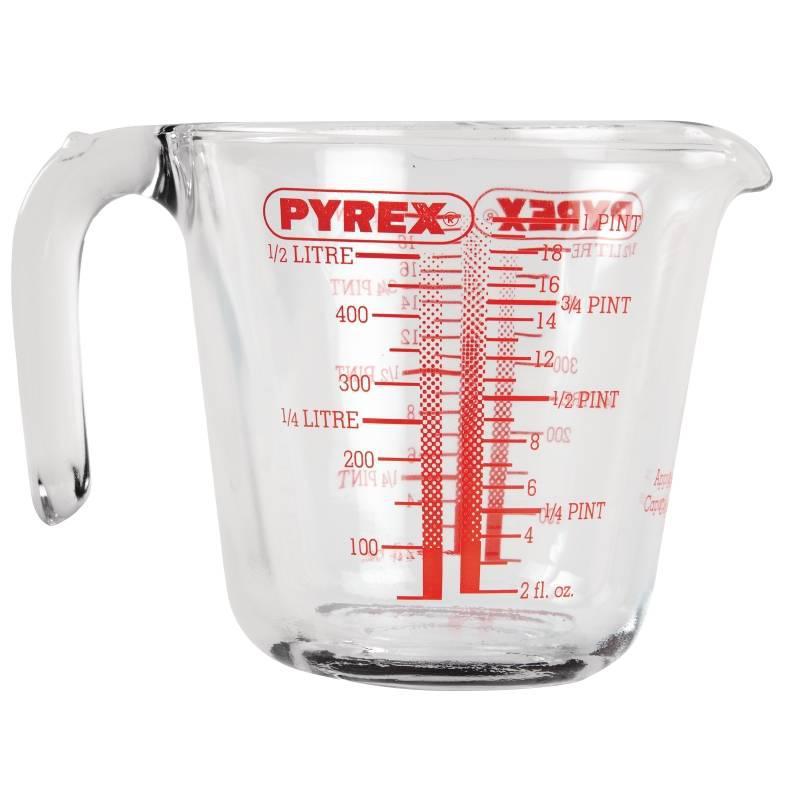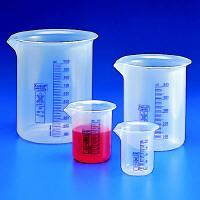The first image is the image on the left, the second image is the image on the right. Assess this claim about the two images: "One image shows beakers filled with at least three different colors of liquid.". Correct or not? Answer yes or no. No. The first image is the image on the left, the second image is the image on the right. Analyze the images presented: Is the assertion "In one image, there is one beaker with a green liquid and one beaker with a red liquid" valid? Answer yes or no. No. 